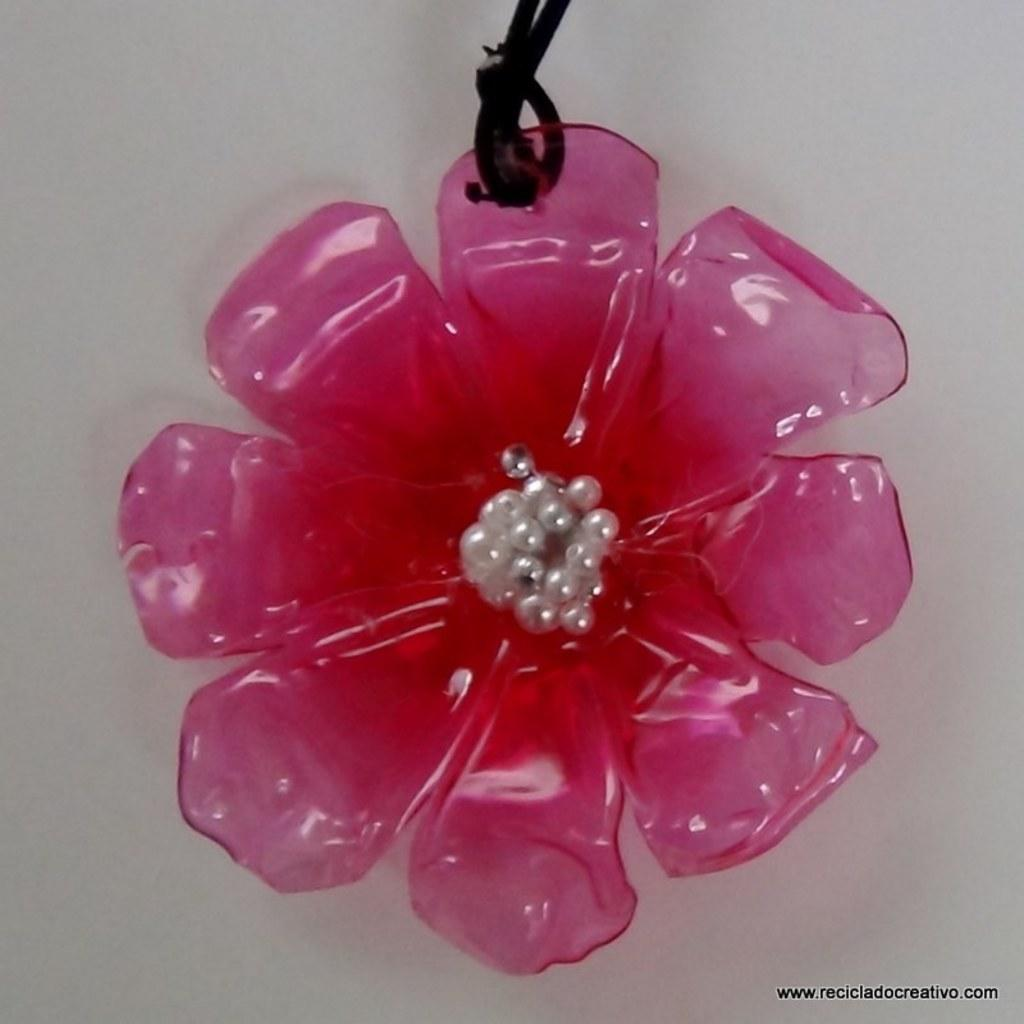What type of object is present in the image? There is a plastic flower in the image. What can be seen in the background of the image? There is a wall in the image. What type of pet can be seen playing with a rake in the image? There is no pet or rake present in the image; it only features a plastic flower and a wall. 